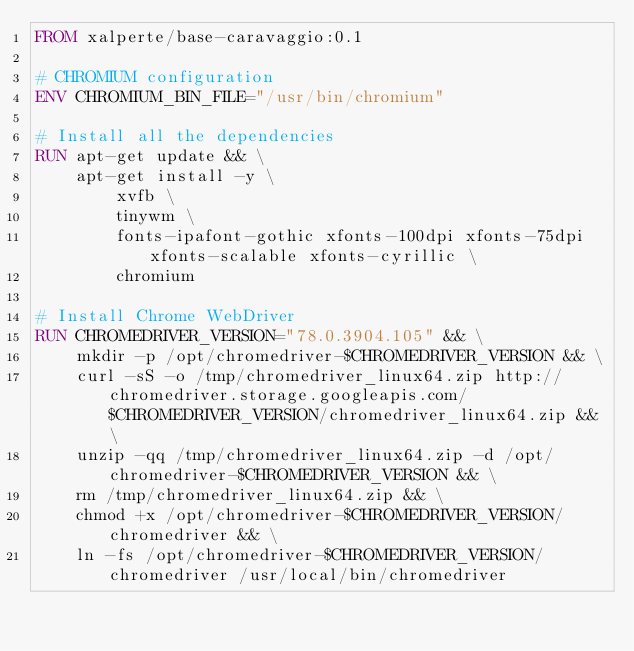Convert code to text. <code><loc_0><loc_0><loc_500><loc_500><_Dockerfile_>FROM xalperte/base-caravaggio:0.1

# CHROMIUM configuration
ENV CHROMIUM_BIN_FILE="/usr/bin/chromium"

# Install all the dependencies
RUN apt-get update && \
    apt-get install -y \
        xvfb \
        tinywm \
        fonts-ipafont-gothic xfonts-100dpi xfonts-75dpi xfonts-scalable xfonts-cyrillic \
        chromium

# Install Chrome WebDriver
RUN CHROMEDRIVER_VERSION="78.0.3904.105" && \
    mkdir -p /opt/chromedriver-$CHROMEDRIVER_VERSION && \
    curl -sS -o /tmp/chromedriver_linux64.zip http://chromedriver.storage.googleapis.com/$CHROMEDRIVER_VERSION/chromedriver_linux64.zip && \
    unzip -qq /tmp/chromedriver_linux64.zip -d /opt/chromedriver-$CHROMEDRIVER_VERSION && \
    rm /tmp/chromedriver_linux64.zip && \
    chmod +x /opt/chromedriver-$CHROMEDRIVER_VERSION/chromedriver && \
    ln -fs /opt/chromedriver-$CHROMEDRIVER_VERSION/chromedriver /usr/local/bin/chromedriver
</code> 